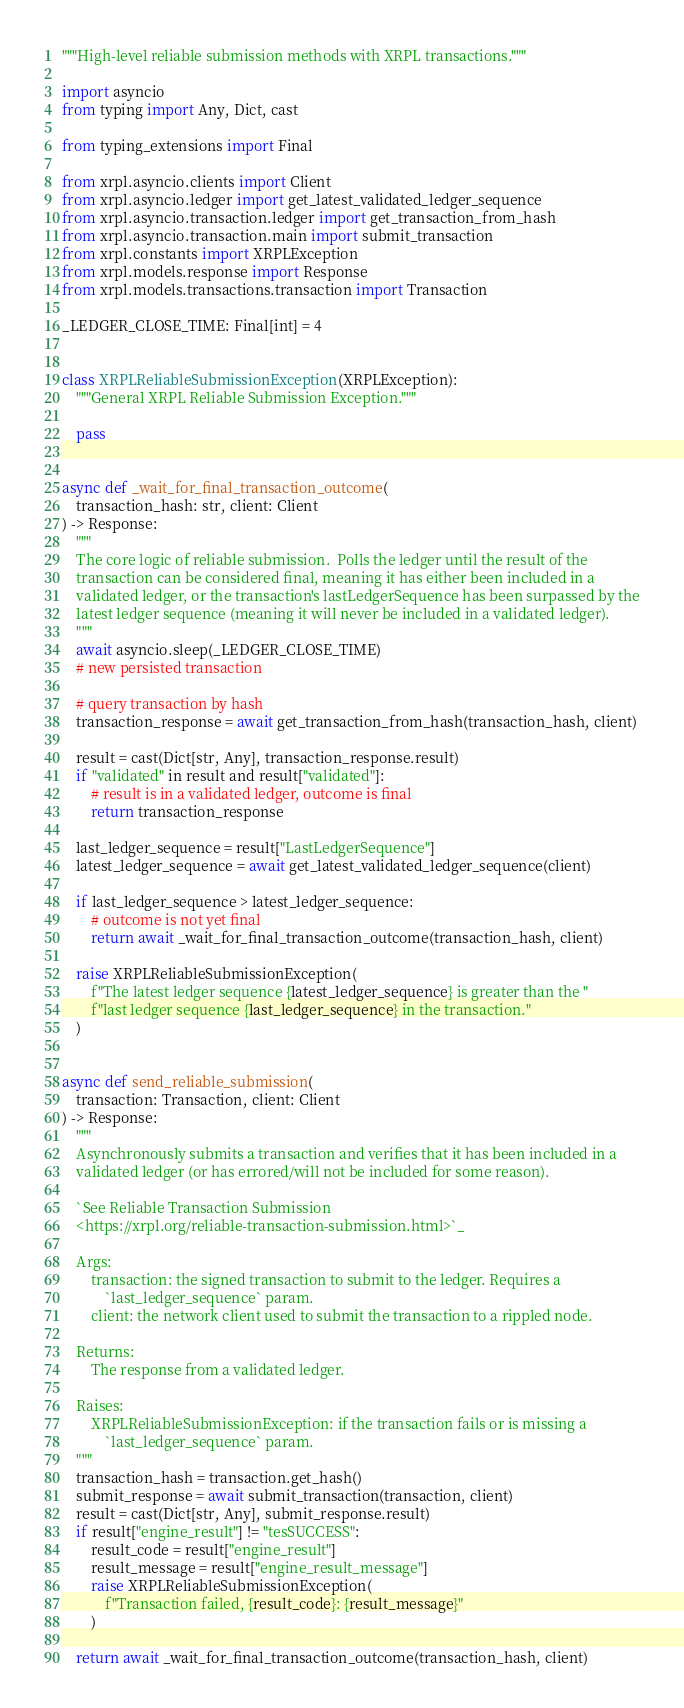<code> <loc_0><loc_0><loc_500><loc_500><_Python_>"""High-level reliable submission methods with XRPL transactions."""

import asyncio
from typing import Any, Dict, cast

from typing_extensions import Final

from xrpl.asyncio.clients import Client
from xrpl.asyncio.ledger import get_latest_validated_ledger_sequence
from xrpl.asyncio.transaction.ledger import get_transaction_from_hash
from xrpl.asyncio.transaction.main import submit_transaction
from xrpl.constants import XRPLException
from xrpl.models.response import Response
from xrpl.models.transactions.transaction import Transaction

_LEDGER_CLOSE_TIME: Final[int] = 4


class XRPLReliableSubmissionException(XRPLException):
    """General XRPL Reliable Submission Exception."""

    pass


async def _wait_for_final_transaction_outcome(
    transaction_hash: str, client: Client
) -> Response:
    """
    The core logic of reliable submission.  Polls the ledger until the result of the
    transaction can be considered final, meaning it has either been included in a
    validated ledger, or the transaction's lastLedgerSequence has been surpassed by the
    latest ledger sequence (meaning it will never be included in a validated ledger).
    """
    await asyncio.sleep(_LEDGER_CLOSE_TIME)
    # new persisted transaction

    # query transaction by hash
    transaction_response = await get_transaction_from_hash(transaction_hash, client)

    result = cast(Dict[str, Any], transaction_response.result)
    if "validated" in result and result["validated"]:
        # result is in a validated ledger, outcome is final
        return transaction_response

    last_ledger_sequence = result["LastLedgerSequence"]
    latest_ledger_sequence = await get_latest_validated_ledger_sequence(client)

    if last_ledger_sequence > latest_ledger_sequence:
        # outcome is not yet final
        return await _wait_for_final_transaction_outcome(transaction_hash, client)

    raise XRPLReliableSubmissionException(
        f"The latest ledger sequence {latest_ledger_sequence} is greater than the "
        f"last ledger sequence {last_ledger_sequence} in the transaction."
    )


async def send_reliable_submission(
    transaction: Transaction, client: Client
) -> Response:
    """
    Asynchronously submits a transaction and verifies that it has been included in a
    validated ledger (or has errored/will not be included for some reason).

    `See Reliable Transaction Submission
    <https://xrpl.org/reliable-transaction-submission.html>`_

    Args:
        transaction: the signed transaction to submit to the ledger. Requires a
            `last_ledger_sequence` param.
        client: the network client used to submit the transaction to a rippled node.

    Returns:
        The response from a validated ledger.

    Raises:
        XRPLReliableSubmissionException: if the transaction fails or is missing a
            `last_ledger_sequence` param.
    """
    transaction_hash = transaction.get_hash()
    submit_response = await submit_transaction(transaction, client)
    result = cast(Dict[str, Any], submit_response.result)
    if result["engine_result"] != "tesSUCCESS":
        result_code = result["engine_result"]
        result_message = result["engine_result_message"]
        raise XRPLReliableSubmissionException(
            f"Transaction failed, {result_code}: {result_message}"
        )

    return await _wait_for_final_transaction_outcome(transaction_hash, client)
</code> 